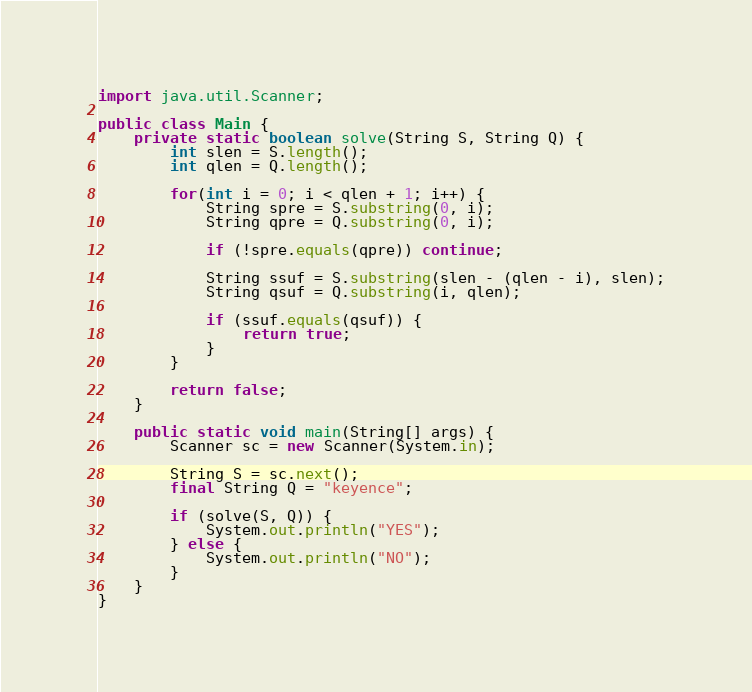<code> <loc_0><loc_0><loc_500><loc_500><_Java_>import java.util.Scanner;

public class Main {
    private static boolean solve(String S, String Q) {
        int slen = S.length();
        int qlen = Q.length();

        for(int i = 0; i < qlen + 1; i++) {
            String spre = S.substring(0, i);
            String qpre = Q.substring(0, i);

            if (!spre.equals(qpre)) continue;

            String ssuf = S.substring(slen - (qlen - i), slen);
            String qsuf = Q.substring(i, qlen);

            if (ssuf.equals(qsuf)) {
                return true;
            }
        }

        return false;
    }

    public static void main(String[] args) {
        Scanner sc = new Scanner(System.in);

        String S = sc.next();
        final String Q = "keyence";

        if (solve(S, Q)) {
            System.out.println("YES");
        } else {
            System.out.println("NO");
        }
    }
}
</code> 